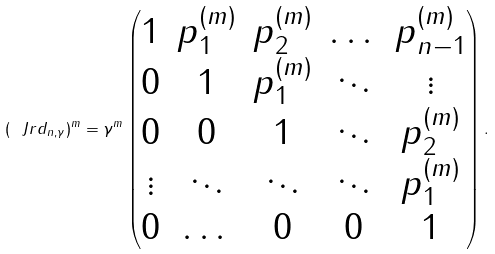<formula> <loc_0><loc_0><loc_500><loc_500>( \ J r d _ { n , \gamma } ) ^ { m } = \gamma ^ { m } \begin{pmatrix} 1 & p _ { 1 } ^ { ( m ) } & p _ { 2 } ^ { ( m ) } & \dots & p _ { n - 1 } ^ { ( m ) } \\ 0 & 1 & p _ { 1 } ^ { ( m ) } & \ddots & \vdots \\ 0 & 0 & 1 & \ddots & p _ { 2 } ^ { ( m ) } \\ \vdots & \ddots & \ddots & \ddots & p _ { 1 } ^ { ( m ) } \\ 0 & \dots & 0 & 0 & 1 \end{pmatrix} .</formula> 